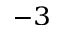<formula> <loc_0><loc_0><loc_500><loc_500>^ { - 3 }</formula> 